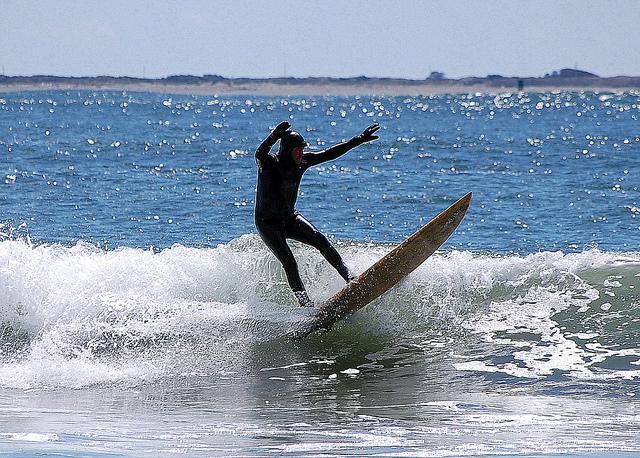What is the man wearing?
Write a very short answer. Wetsuit. Will this person fall down?
Quick response, please. Yes. Is the man on the surfboard naked?
Quick response, please. No. 